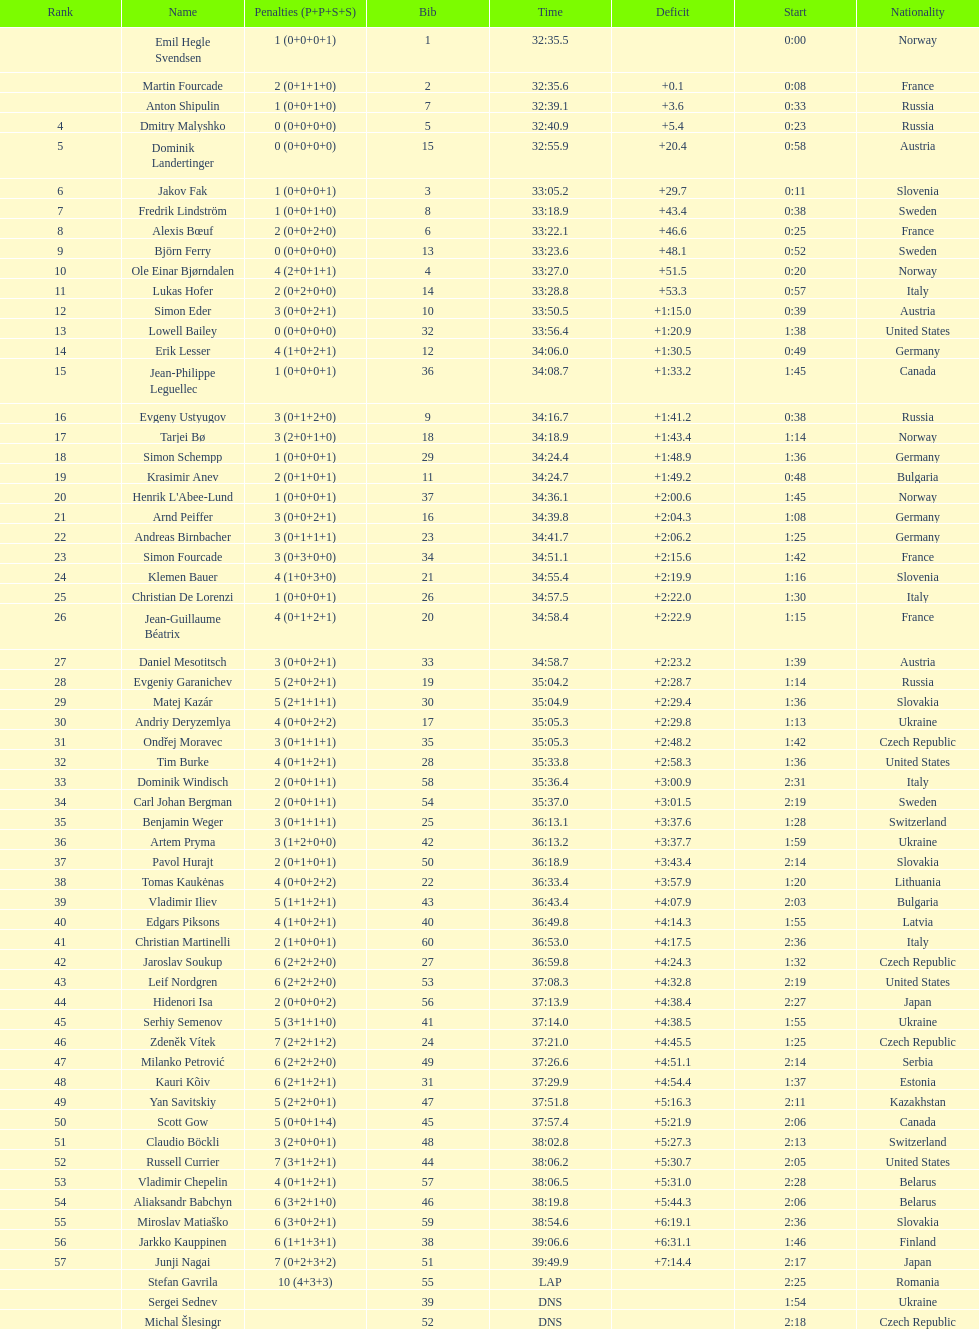What is the total number of participants between norway and france? 7. 